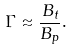<formula> <loc_0><loc_0><loc_500><loc_500>\Gamma \approx \frac { B _ { t } } { B _ { p } } .</formula> 